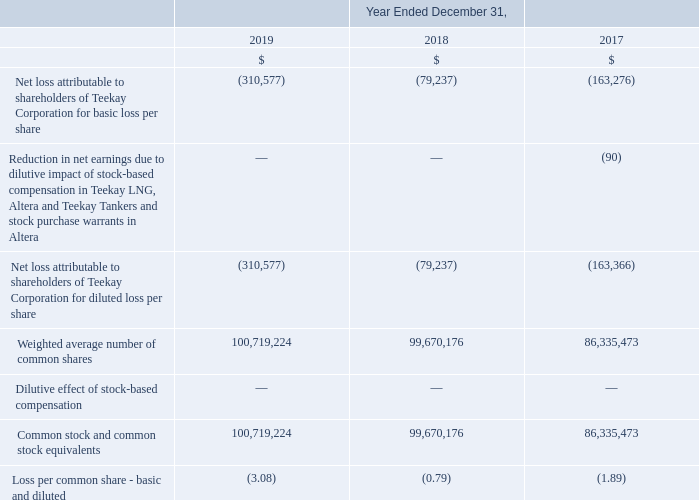20. Net Loss Per Share
The Company intends to settle the principal of the Convertible Notes in cash on conversion and calculates diluted earnings per share using the treasury-stock method. Stock-based awards and the conversion feature on the Convertible Notes that have an anti-dilutive effect on the calculation of diluted loss per common share, are excluded from this calculation.
For the years ended December 31, 2019, 2018 and 2017, the number of Common Stock from stock-based awards and the conversion feature on the Convertible Notes that had an anti-dilutive effect on the calculation of diluted earnings per common share were 3.5 million, 4.0 million and 3.6 million respectively.
In periods where a loss attributable to shareholders has been incurred all stock-based awards and the conversion feature on the Convertible Notes are anti-dilutive.
Which method is used for to settle the principal of the Convertible Notes in cash on conversion and calculates diluted earnings? The company intends to settle the principal of the convertible notes in cash on conversion and calculates diluted earnings per share using the treasury-stock method. What happens if a loss attributable to shareholders has been incurred? In periods where a loss attributable to shareholders has been incurred all stock-based awards and the conversion feature on the convertible notes are anti-dilutive. What was the Convertible Notes that had an anti-dilutive effect on the calculation of diluted earnings per common share in the year end 2019, 2018 and 2017? For the years ended december 31, 2019, 2018 and 2017, the number of common stock from stock-based awards and the conversion feature on the convertible notes that had an anti-dilutive effect on the calculation of diluted earnings per common share were 3.5 million, 4.0 million and 3.6 million respectively. What is the increase/ (decrease) in Net loss attributable to shareholders of Teekay Corporation for basic loss per share from 2018 to 2019?
Answer scale should be: million. 310,577-79,237
Answer: 231340. What is the increase/ (decrease) in Weighted average number of common shares from 2018 to 2019?
Answer scale should be: million. 100,719,224-99,670,176
Answer: 1049048. What is the increase/ (decrease) in Loss per common share - basic and diluted from 2018 to 2019?
Answer scale should be: million. 3.08-0.79
Answer: 2.29. 